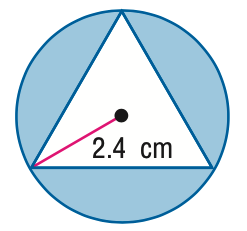Question: Find the area of the shaded region. Assume that all polygons that appear to be regular are regular. Round to the nearest tenth.
Choices:
A. 10.6
B. 15.2
C. 15.6
D. 18.1
Answer with the letter. Answer: A 